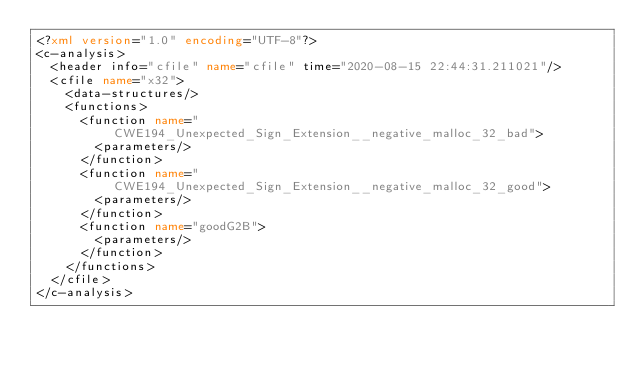<code> <loc_0><loc_0><loc_500><loc_500><_XML_><?xml version="1.0" encoding="UTF-8"?>
<c-analysis>
  <header info="cfile" name="cfile" time="2020-08-15 22:44:31.211021"/>
  <cfile name="x32">
    <data-structures/>
    <functions>
      <function name="CWE194_Unexpected_Sign_Extension__negative_malloc_32_bad">
        <parameters/>
      </function>
      <function name="CWE194_Unexpected_Sign_Extension__negative_malloc_32_good">
        <parameters/>
      </function>
      <function name="goodG2B">
        <parameters/>
      </function>
    </functions>
  </cfile>
</c-analysis>
</code> 